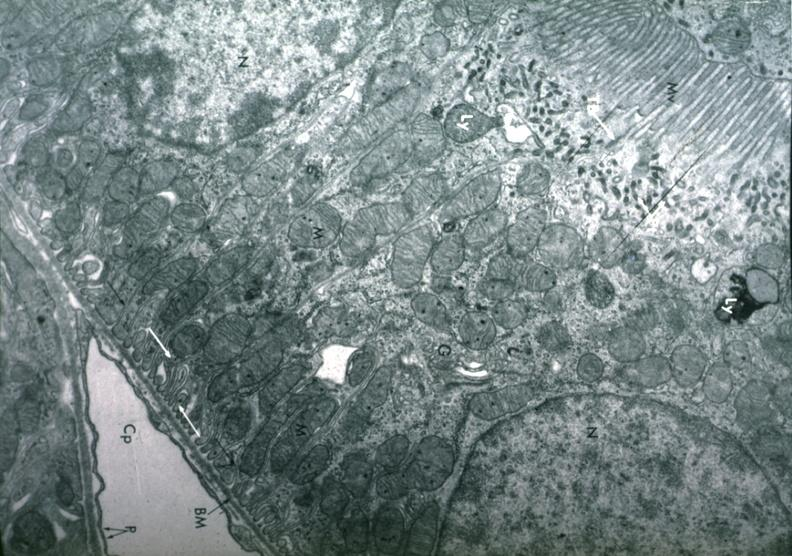what is present?
Answer the question using a single word or phrase. Normal proximal tubule cell 